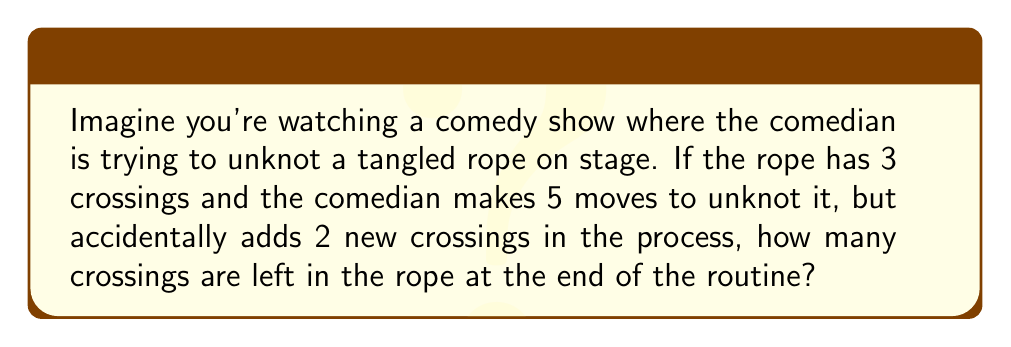Can you answer this question? Let's break this down step-by-step:

1. Initial state: The rope starts with 3 crossings.

2. The comedian's actions:
   - Makes 5 moves to unknot the rope
   - Accidentally adds 2 new crossings

3. Let's consider what these moves might do:
   - In the best-case scenario, each move could remove one crossing
   - However, we know that not all moves were successful because new crossings were added

4. Let's calculate:
   - Initial crossings: 3
   - Maximum crossings removed: 5 (one per move)
   - New crossings added: 2

5. We can express this mathematically:
   $$\text{Final crossings} = \text{Initial crossings} - \text{Removed crossings} + \text{Added crossings}$$
   $$\text{Final crossings} = 3 - 5 + 2 = 0$$

6. However, we can't have a negative number of crossings in a real rope. So if the comedian removed all initial crossings and added 2 new ones, we'd end up with:
   $$\text{Final crossings} = 0 + 2 = 2$$

Therefore, at the end of the routine, the rope has 2 crossings left.
Answer: 2 crossings 